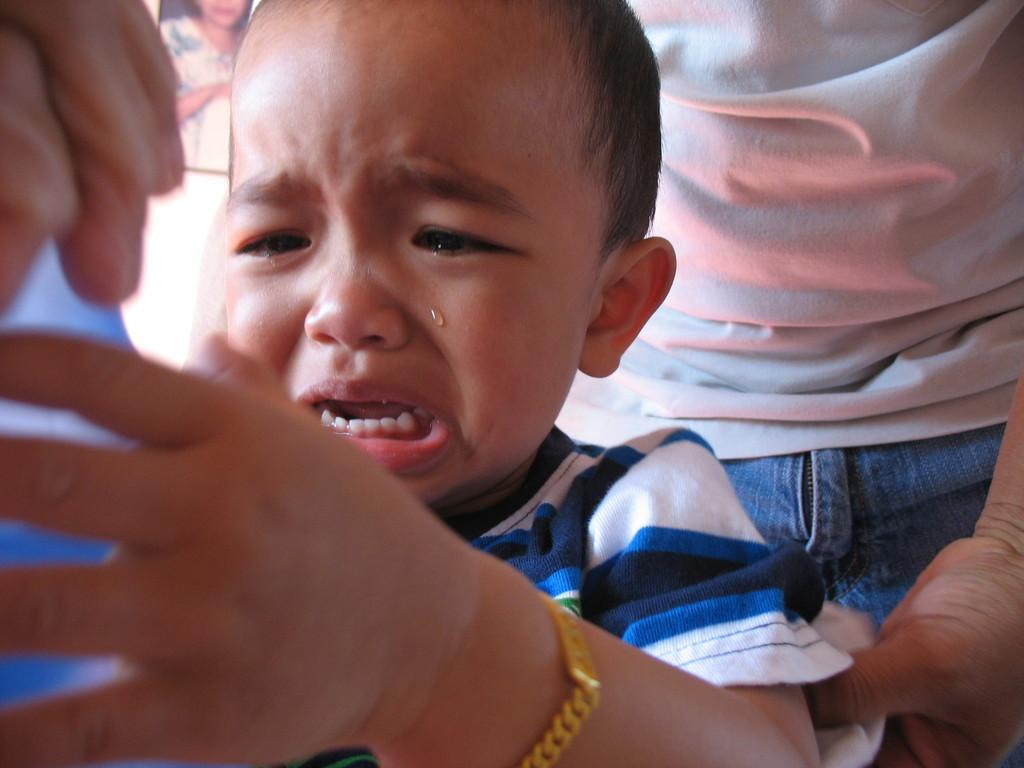What is the emotional state of the kid in the image? The kid in the image is crying. What accessory is the kid wearing? The kid is wearing a bracelet. Can you describe the person behind the kid? The person behind the kid is wearing a white t-shirt. What type of cord is being used to measure the depth of the basin in the image? There is no cord or basin present in the image; it features a crying kid and a person behind them. What season is depicted in the image, considering the clothing of the person behind the kid? The clothing of the person behind the kid (a white t-shirt) does not provide any information about the season, as white t-shirts can be worn in various seasons. 